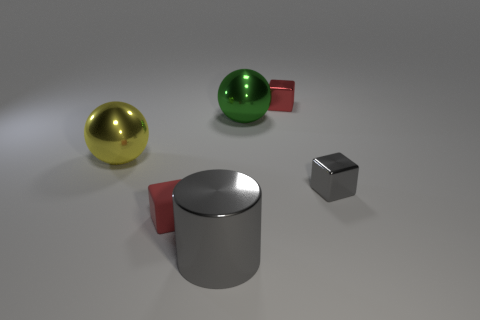Add 3 matte things. How many objects exist? 9 Subtract all cylinders. How many objects are left? 5 Subtract all tiny red rubber things. Subtract all large yellow metal objects. How many objects are left? 4 Add 2 yellow shiny balls. How many yellow shiny balls are left? 3 Add 6 big shiny balls. How many big shiny balls exist? 8 Subtract 1 gray blocks. How many objects are left? 5 